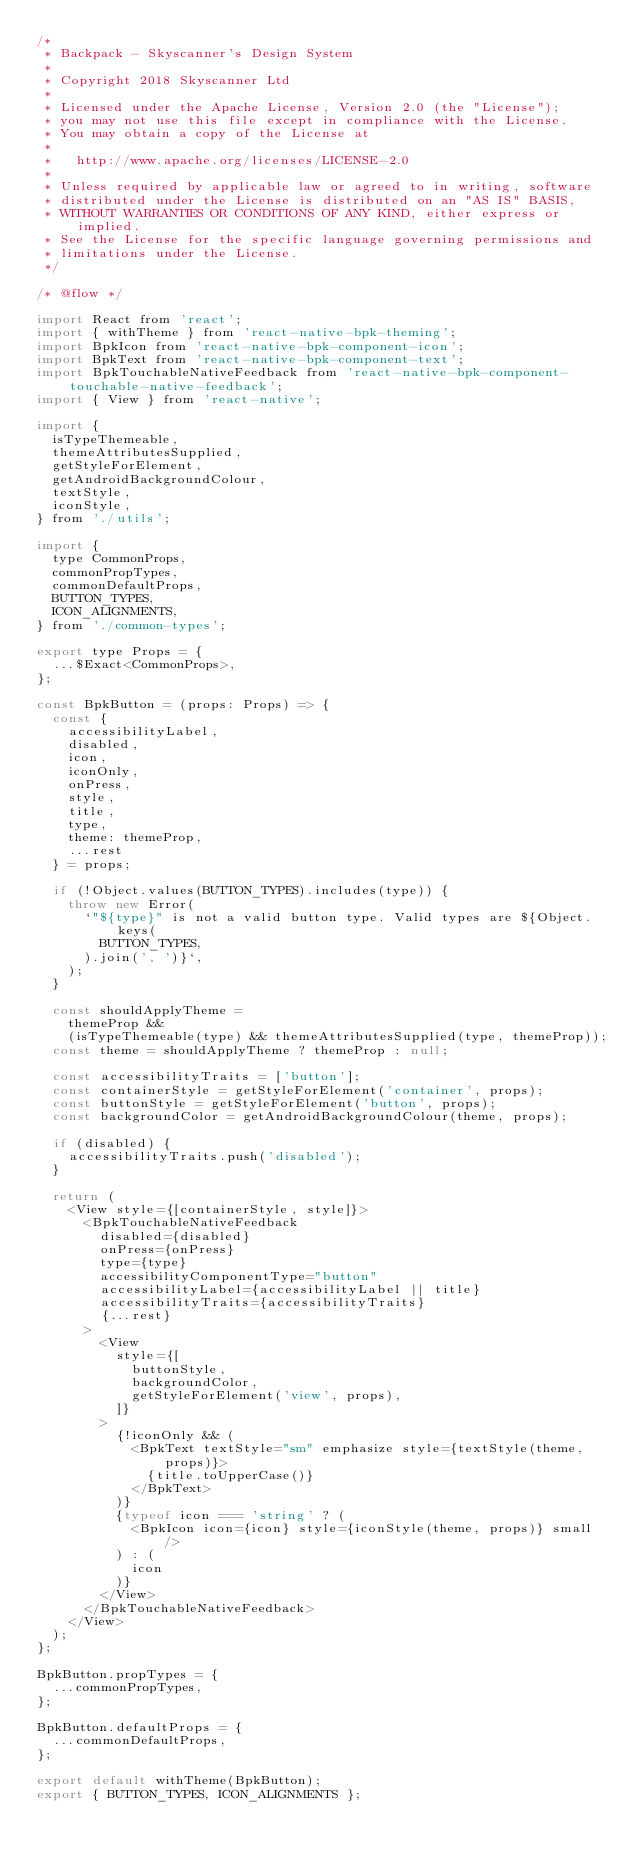<code> <loc_0><loc_0><loc_500><loc_500><_JavaScript_>/*
 * Backpack - Skyscanner's Design System
 *
 * Copyright 2018 Skyscanner Ltd
 *
 * Licensed under the Apache License, Version 2.0 (the "License");
 * you may not use this file except in compliance with the License.
 * You may obtain a copy of the License at
 *
 *   http://www.apache.org/licenses/LICENSE-2.0
 *
 * Unless required by applicable law or agreed to in writing, software
 * distributed under the License is distributed on an "AS IS" BASIS,
 * WITHOUT WARRANTIES OR CONDITIONS OF ANY KIND, either express or implied.
 * See the License for the specific language governing permissions and
 * limitations under the License.
 */

/* @flow */

import React from 'react';
import { withTheme } from 'react-native-bpk-theming';
import BpkIcon from 'react-native-bpk-component-icon';
import BpkText from 'react-native-bpk-component-text';
import BpkTouchableNativeFeedback from 'react-native-bpk-component-touchable-native-feedback';
import { View } from 'react-native';

import {
  isTypeThemeable,
  themeAttributesSupplied,
  getStyleForElement,
  getAndroidBackgroundColour,
  textStyle,
  iconStyle,
} from './utils';

import {
  type CommonProps,
  commonPropTypes,
  commonDefaultProps,
  BUTTON_TYPES,
  ICON_ALIGNMENTS,
} from './common-types';

export type Props = {
  ...$Exact<CommonProps>,
};

const BpkButton = (props: Props) => {
  const {
    accessibilityLabel,
    disabled,
    icon,
    iconOnly,
    onPress,
    style,
    title,
    type,
    theme: themeProp,
    ...rest
  } = props;

  if (!Object.values(BUTTON_TYPES).includes(type)) {
    throw new Error(
      `"${type}" is not a valid button type. Valid types are ${Object.keys(
        BUTTON_TYPES,
      ).join(', ')}`,
    );
  }

  const shouldApplyTheme =
    themeProp &&
    (isTypeThemeable(type) && themeAttributesSupplied(type, themeProp));
  const theme = shouldApplyTheme ? themeProp : null;

  const accessibilityTraits = ['button'];
  const containerStyle = getStyleForElement('container', props);
  const buttonStyle = getStyleForElement('button', props);
  const backgroundColor = getAndroidBackgroundColour(theme, props);

  if (disabled) {
    accessibilityTraits.push('disabled');
  }

  return (
    <View style={[containerStyle, style]}>
      <BpkTouchableNativeFeedback
        disabled={disabled}
        onPress={onPress}
        type={type}
        accessibilityComponentType="button"
        accessibilityLabel={accessibilityLabel || title}
        accessibilityTraits={accessibilityTraits}
        {...rest}
      >
        <View
          style={[
            buttonStyle,
            backgroundColor,
            getStyleForElement('view', props),
          ]}
        >
          {!iconOnly && (
            <BpkText textStyle="sm" emphasize style={textStyle(theme, props)}>
              {title.toUpperCase()}
            </BpkText>
          )}
          {typeof icon === 'string' ? (
            <BpkIcon icon={icon} style={iconStyle(theme, props)} small />
          ) : (
            icon
          )}
        </View>
      </BpkTouchableNativeFeedback>
    </View>
  );
};

BpkButton.propTypes = {
  ...commonPropTypes,
};

BpkButton.defaultProps = {
  ...commonDefaultProps,
};

export default withTheme(BpkButton);
export { BUTTON_TYPES, ICON_ALIGNMENTS };
</code> 